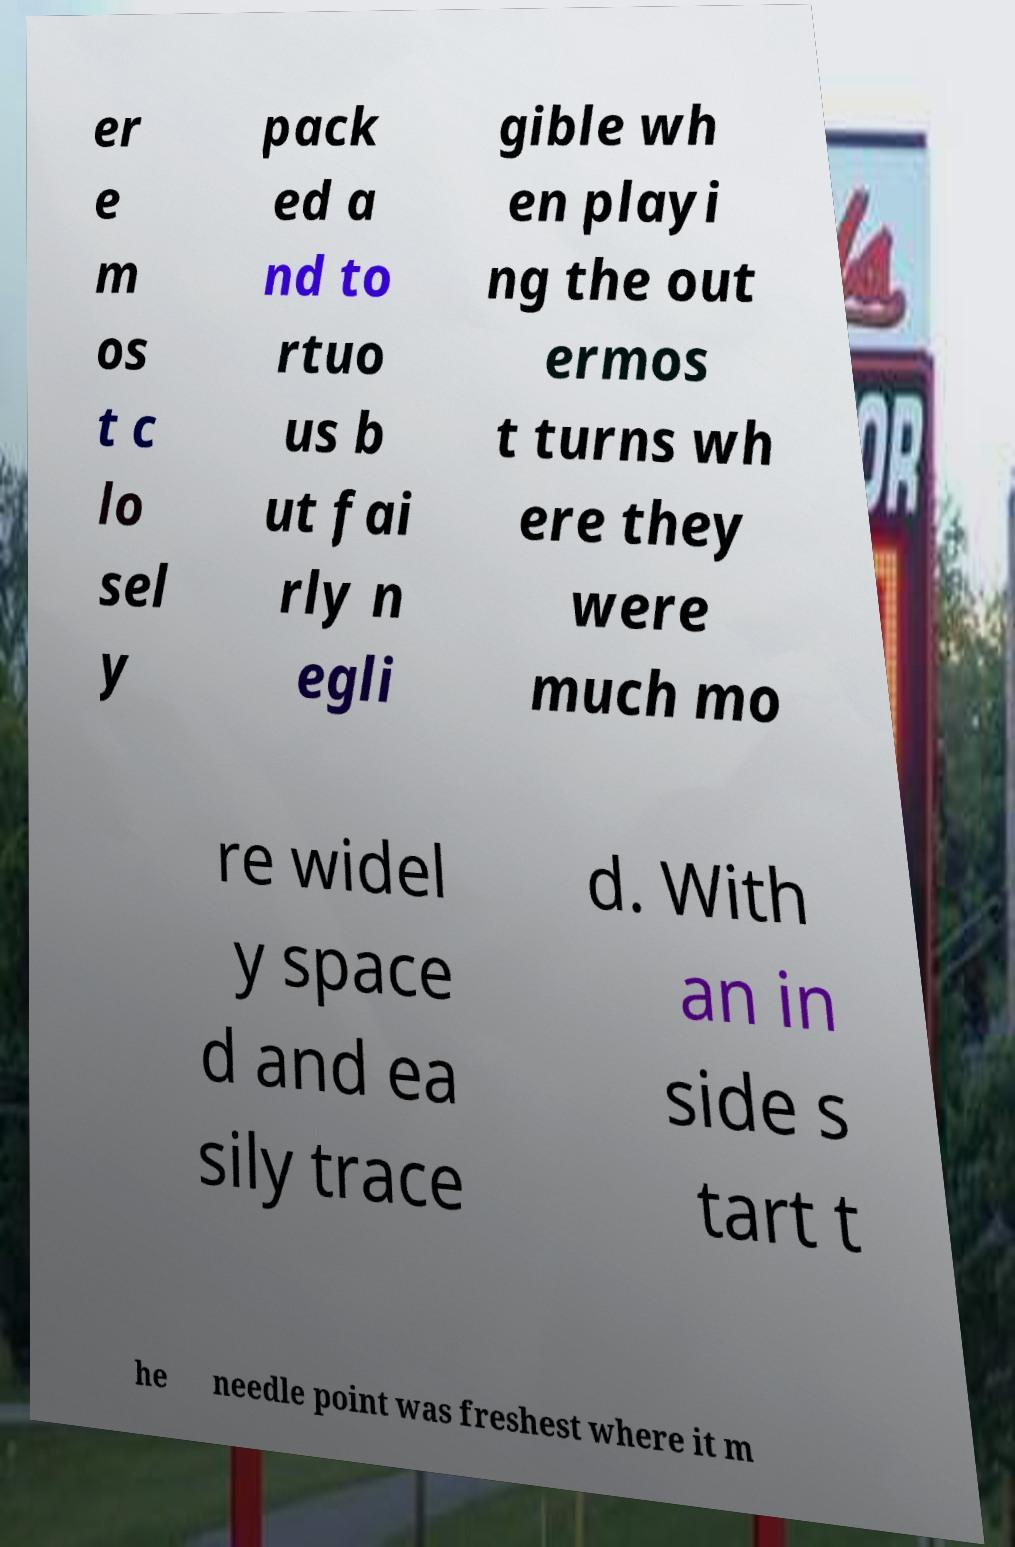Could you assist in decoding the text presented in this image and type it out clearly? er e m os t c lo sel y pack ed a nd to rtuo us b ut fai rly n egli gible wh en playi ng the out ermos t turns wh ere they were much mo re widel y space d and ea sily trace d. With an in side s tart t he needle point was freshest where it m 